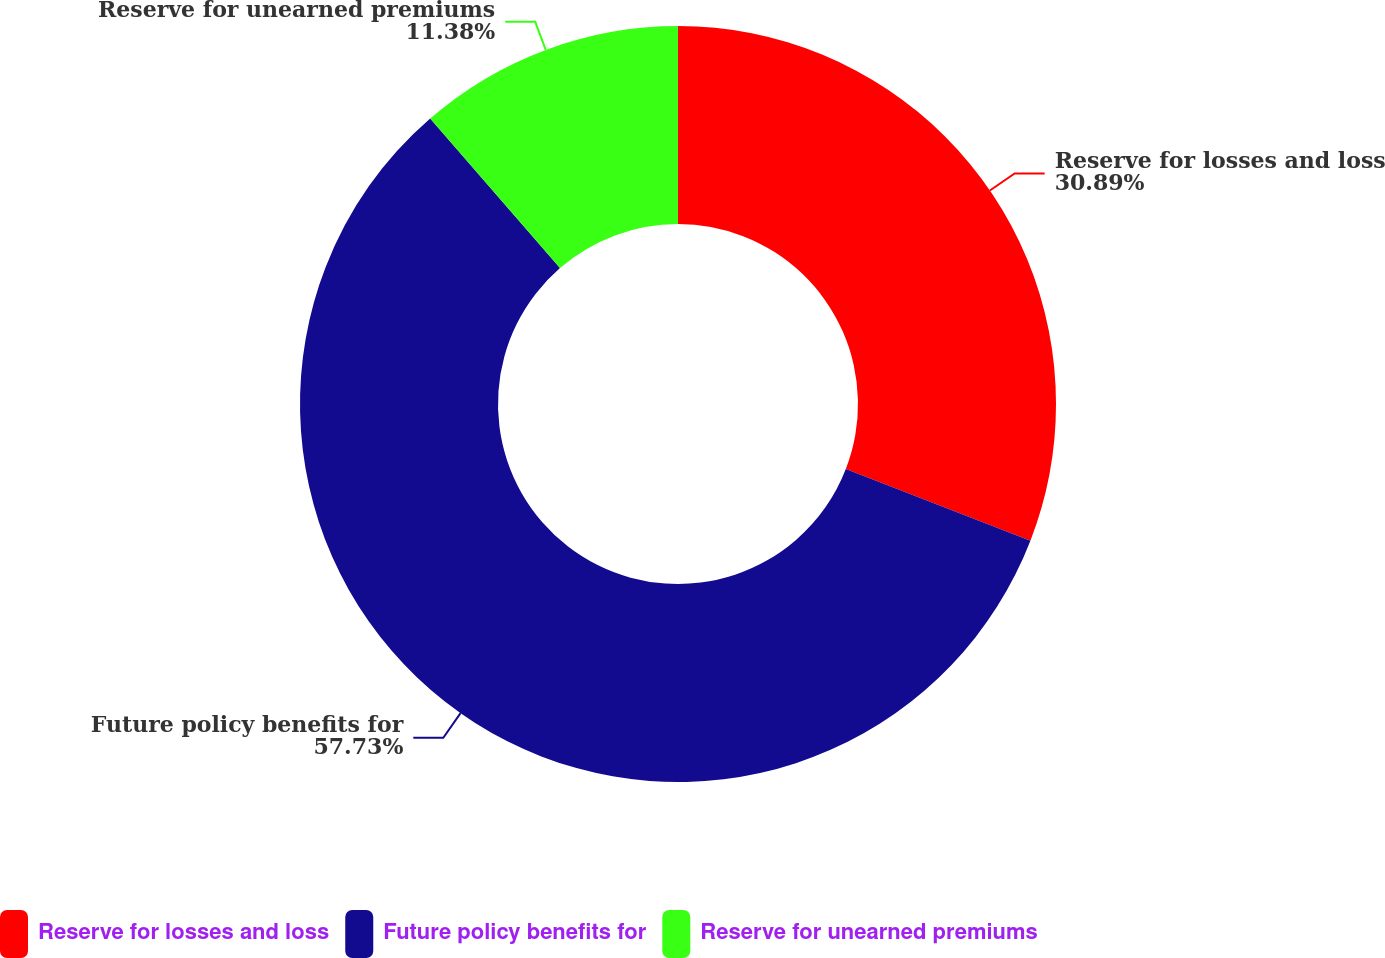<chart> <loc_0><loc_0><loc_500><loc_500><pie_chart><fcel>Reserve for losses and loss<fcel>Future policy benefits for<fcel>Reserve for unearned premiums<nl><fcel>30.89%<fcel>57.73%<fcel>11.38%<nl></chart> 